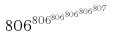<formula> <loc_0><loc_0><loc_500><loc_500>8 0 6 ^ { 8 0 6 ^ { 8 0 6 ^ { 8 0 6 ^ { 8 0 6 ^ { 8 0 7 } } } } }</formula> 